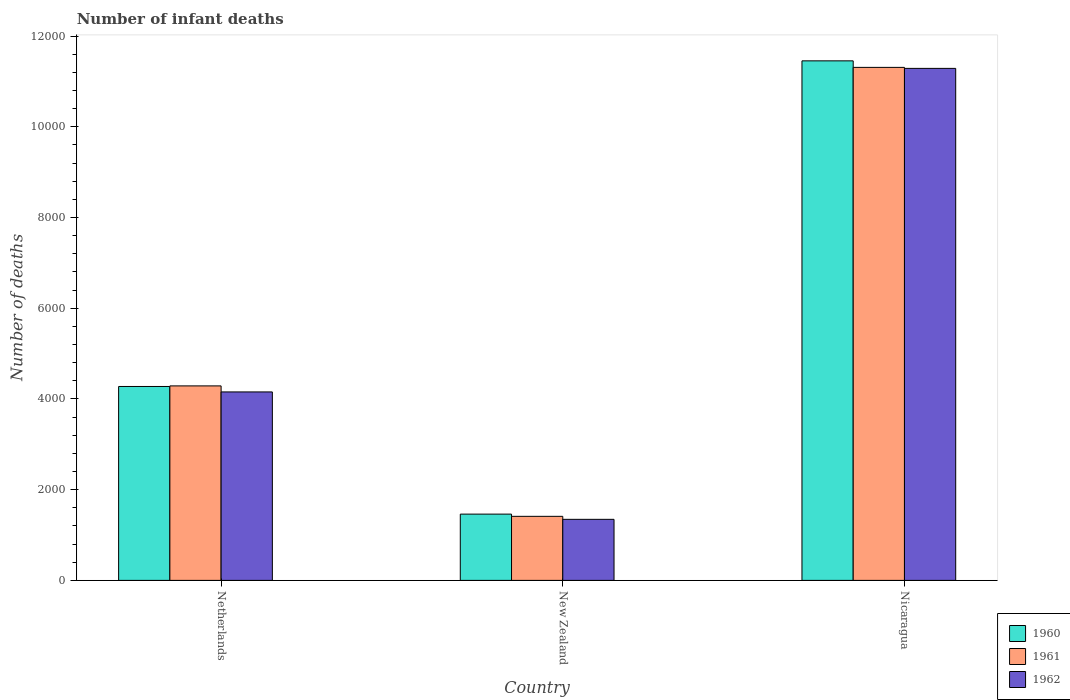How many groups of bars are there?
Provide a succinct answer. 3. Are the number of bars on each tick of the X-axis equal?
Make the answer very short. Yes. How many bars are there on the 2nd tick from the right?
Offer a terse response. 3. What is the label of the 1st group of bars from the left?
Make the answer very short. Netherlands. In how many cases, is the number of bars for a given country not equal to the number of legend labels?
Keep it short and to the point. 0. What is the number of infant deaths in 1961 in Netherlands?
Your response must be concise. 4288. Across all countries, what is the maximum number of infant deaths in 1962?
Provide a succinct answer. 1.13e+04. Across all countries, what is the minimum number of infant deaths in 1962?
Give a very brief answer. 1346. In which country was the number of infant deaths in 1960 maximum?
Your response must be concise. Nicaragua. In which country was the number of infant deaths in 1962 minimum?
Your response must be concise. New Zealand. What is the total number of infant deaths in 1960 in the graph?
Offer a terse response. 1.72e+04. What is the difference between the number of infant deaths in 1960 in Netherlands and that in New Zealand?
Your response must be concise. 2814. What is the difference between the number of infant deaths in 1962 in Nicaragua and the number of infant deaths in 1960 in New Zealand?
Make the answer very short. 9827. What is the average number of infant deaths in 1961 per country?
Give a very brief answer. 5670. What is the difference between the number of infant deaths of/in 1962 and number of infant deaths of/in 1961 in Nicaragua?
Make the answer very short. -22. What is the ratio of the number of infant deaths in 1962 in Netherlands to that in Nicaragua?
Ensure brevity in your answer.  0.37. Is the number of infant deaths in 1961 in New Zealand less than that in Nicaragua?
Provide a succinct answer. Yes. Is the difference between the number of infant deaths in 1962 in Netherlands and New Zealand greater than the difference between the number of infant deaths in 1961 in Netherlands and New Zealand?
Offer a terse response. No. What is the difference between the highest and the second highest number of infant deaths in 1960?
Your answer should be compact. 2814. What is the difference between the highest and the lowest number of infant deaths in 1962?
Give a very brief answer. 9942. Is the sum of the number of infant deaths in 1960 in Netherlands and Nicaragua greater than the maximum number of infant deaths in 1961 across all countries?
Offer a terse response. Yes. What does the 2nd bar from the left in Nicaragua represents?
Ensure brevity in your answer.  1961. What does the 1st bar from the right in Nicaragua represents?
Keep it short and to the point. 1962. How many bars are there?
Your answer should be compact. 9. Are all the bars in the graph horizontal?
Ensure brevity in your answer.  No. How many countries are there in the graph?
Your answer should be compact. 3. What is the difference between two consecutive major ticks on the Y-axis?
Your answer should be very brief. 2000. What is the title of the graph?
Give a very brief answer. Number of infant deaths. What is the label or title of the X-axis?
Offer a terse response. Country. What is the label or title of the Y-axis?
Offer a terse response. Number of deaths. What is the Number of deaths of 1960 in Netherlands?
Give a very brief answer. 4275. What is the Number of deaths of 1961 in Netherlands?
Your answer should be very brief. 4288. What is the Number of deaths of 1962 in Netherlands?
Your answer should be very brief. 4155. What is the Number of deaths of 1960 in New Zealand?
Keep it short and to the point. 1461. What is the Number of deaths of 1961 in New Zealand?
Your answer should be very brief. 1412. What is the Number of deaths in 1962 in New Zealand?
Give a very brief answer. 1346. What is the Number of deaths of 1960 in Nicaragua?
Offer a terse response. 1.15e+04. What is the Number of deaths in 1961 in Nicaragua?
Your answer should be very brief. 1.13e+04. What is the Number of deaths in 1962 in Nicaragua?
Ensure brevity in your answer.  1.13e+04. Across all countries, what is the maximum Number of deaths of 1960?
Ensure brevity in your answer.  1.15e+04. Across all countries, what is the maximum Number of deaths of 1961?
Your answer should be compact. 1.13e+04. Across all countries, what is the maximum Number of deaths in 1962?
Make the answer very short. 1.13e+04. Across all countries, what is the minimum Number of deaths of 1960?
Your answer should be compact. 1461. Across all countries, what is the minimum Number of deaths in 1961?
Ensure brevity in your answer.  1412. Across all countries, what is the minimum Number of deaths in 1962?
Offer a very short reply. 1346. What is the total Number of deaths in 1960 in the graph?
Ensure brevity in your answer.  1.72e+04. What is the total Number of deaths of 1961 in the graph?
Your answer should be compact. 1.70e+04. What is the total Number of deaths of 1962 in the graph?
Your answer should be very brief. 1.68e+04. What is the difference between the Number of deaths in 1960 in Netherlands and that in New Zealand?
Your answer should be compact. 2814. What is the difference between the Number of deaths of 1961 in Netherlands and that in New Zealand?
Offer a terse response. 2876. What is the difference between the Number of deaths in 1962 in Netherlands and that in New Zealand?
Provide a short and direct response. 2809. What is the difference between the Number of deaths of 1960 in Netherlands and that in Nicaragua?
Your answer should be compact. -7179. What is the difference between the Number of deaths in 1961 in Netherlands and that in Nicaragua?
Ensure brevity in your answer.  -7022. What is the difference between the Number of deaths of 1962 in Netherlands and that in Nicaragua?
Give a very brief answer. -7133. What is the difference between the Number of deaths in 1960 in New Zealand and that in Nicaragua?
Offer a very short reply. -9993. What is the difference between the Number of deaths of 1961 in New Zealand and that in Nicaragua?
Keep it short and to the point. -9898. What is the difference between the Number of deaths of 1962 in New Zealand and that in Nicaragua?
Provide a succinct answer. -9942. What is the difference between the Number of deaths of 1960 in Netherlands and the Number of deaths of 1961 in New Zealand?
Your answer should be very brief. 2863. What is the difference between the Number of deaths in 1960 in Netherlands and the Number of deaths in 1962 in New Zealand?
Give a very brief answer. 2929. What is the difference between the Number of deaths in 1961 in Netherlands and the Number of deaths in 1962 in New Zealand?
Your answer should be very brief. 2942. What is the difference between the Number of deaths in 1960 in Netherlands and the Number of deaths in 1961 in Nicaragua?
Offer a very short reply. -7035. What is the difference between the Number of deaths in 1960 in Netherlands and the Number of deaths in 1962 in Nicaragua?
Your response must be concise. -7013. What is the difference between the Number of deaths in 1961 in Netherlands and the Number of deaths in 1962 in Nicaragua?
Provide a succinct answer. -7000. What is the difference between the Number of deaths in 1960 in New Zealand and the Number of deaths in 1961 in Nicaragua?
Your response must be concise. -9849. What is the difference between the Number of deaths in 1960 in New Zealand and the Number of deaths in 1962 in Nicaragua?
Your response must be concise. -9827. What is the difference between the Number of deaths of 1961 in New Zealand and the Number of deaths of 1962 in Nicaragua?
Your answer should be compact. -9876. What is the average Number of deaths of 1960 per country?
Your answer should be compact. 5730. What is the average Number of deaths in 1961 per country?
Ensure brevity in your answer.  5670. What is the average Number of deaths in 1962 per country?
Make the answer very short. 5596.33. What is the difference between the Number of deaths of 1960 and Number of deaths of 1961 in Netherlands?
Provide a short and direct response. -13. What is the difference between the Number of deaths in 1960 and Number of deaths in 1962 in Netherlands?
Ensure brevity in your answer.  120. What is the difference between the Number of deaths in 1961 and Number of deaths in 1962 in Netherlands?
Give a very brief answer. 133. What is the difference between the Number of deaths of 1960 and Number of deaths of 1961 in New Zealand?
Make the answer very short. 49. What is the difference between the Number of deaths in 1960 and Number of deaths in 1962 in New Zealand?
Offer a terse response. 115. What is the difference between the Number of deaths of 1960 and Number of deaths of 1961 in Nicaragua?
Provide a succinct answer. 144. What is the difference between the Number of deaths of 1960 and Number of deaths of 1962 in Nicaragua?
Offer a terse response. 166. What is the ratio of the Number of deaths of 1960 in Netherlands to that in New Zealand?
Give a very brief answer. 2.93. What is the ratio of the Number of deaths of 1961 in Netherlands to that in New Zealand?
Your answer should be very brief. 3.04. What is the ratio of the Number of deaths of 1962 in Netherlands to that in New Zealand?
Keep it short and to the point. 3.09. What is the ratio of the Number of deaths in 1960 in Netherlands to that in Nicaragua?
Provide a short and direct response. 0.37. What is the ratio of the Number of deaths of 1961 in Netherlands to that in Nicaragua?
Offer a very short reply. 0.38. What is the ratio of the Number of deaths in 1962 in Netherlands to that in Nicaragua?
Your response must be concise. 0.37. What is the ratio of the Number of deaths of 1960 in New Zealand to that in Nicaragua?
Your answer should be compact. 0.13. What is the ratio of the Number of deaths of 1961 in New Zealand to that in Nicaragua?
Give a very brief answer. 0.12. What is the ratio of the Number of deaths of 1962 in New Zealand to that in Nicaragua?
Make the answer very short. 0.12. What is the difference between the highest and the second highest Number of deaths of 1960?
Give a very brief answer. 7179. What is the difference between the highest and the second highest Number of deaths in 1961?
Provide a succinct answer. 7022. What is the difference between the highest and the second highest Number of deaths of 1962?
Provide a short and direct response. 7133. What is the difference between the highest and the lowest Number of deaths of 1960?
Give a very brief answer. 9993. What is the difference between the highest and the lowest Number of deaths of 1961?
Offer a very short reply. 9898. What is the difference between the highest and the lowest Number of deaths of 1962?
Offer a very short reply. 9942. 